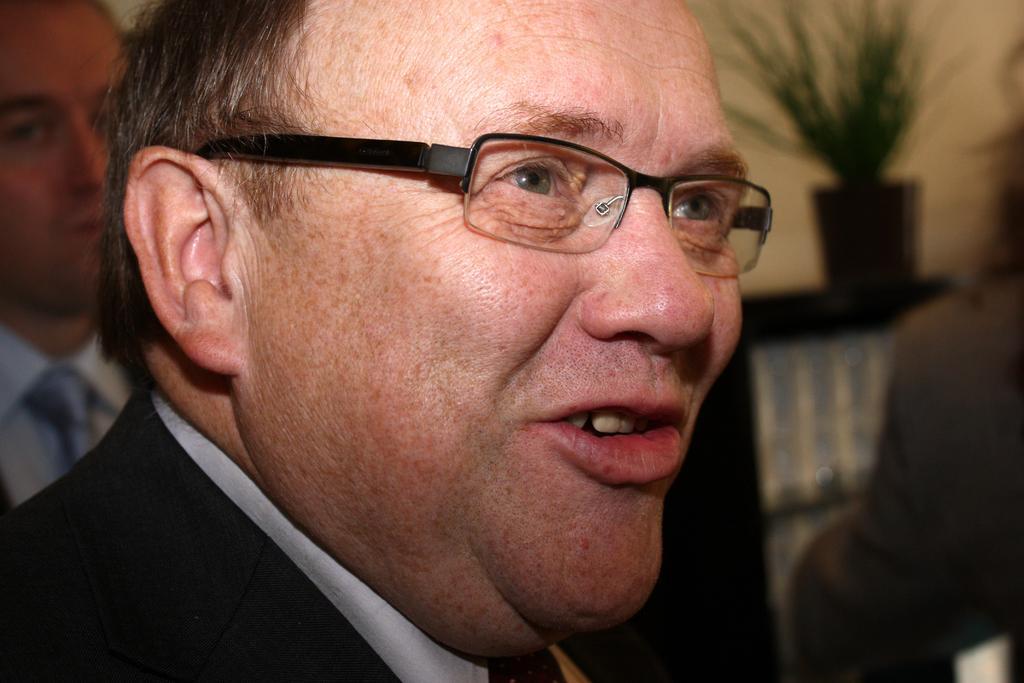Can you describe this image briefly? In this picture there is a person wearing black suit and spectacles is speaking and there is another person behind him. 